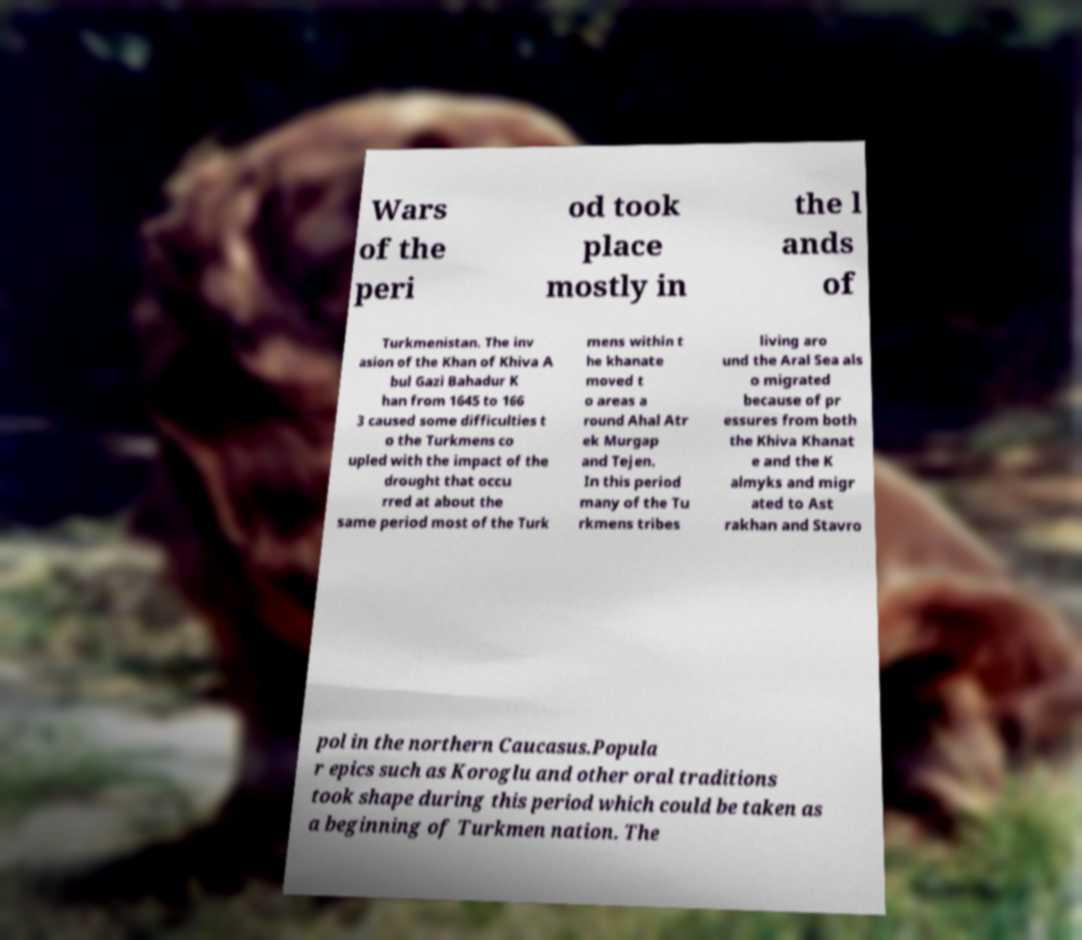There's text embedded in this image that I need extracted. Can you transcribe it verbatim? Wars of the peri od took place mostly in the l ands of Turkmenistan. The inv asion of the Khan of Khiva A bul Gazi Bahadur K han from 1645 to 166 3 caused some difficulties t o the Turkmens co upled with the impact of the drought that occu rred at about the same period most of the Turk mens within t he khanate moved t o areas a round Ahal Atr ek Murgap and Tejen. In this period many of the Tu rkmens tribes living aro und the Aral Sea als o migrated because of pr essures from both the Khiva Khanat e and the K almyks and migr ated to Ast rakhan and Stavro pol in the northern Caucasus.Popula r epics such as Koroglu and other oral traditions took shape during this period which could be taken as a beginning of Turkmen nation. The 